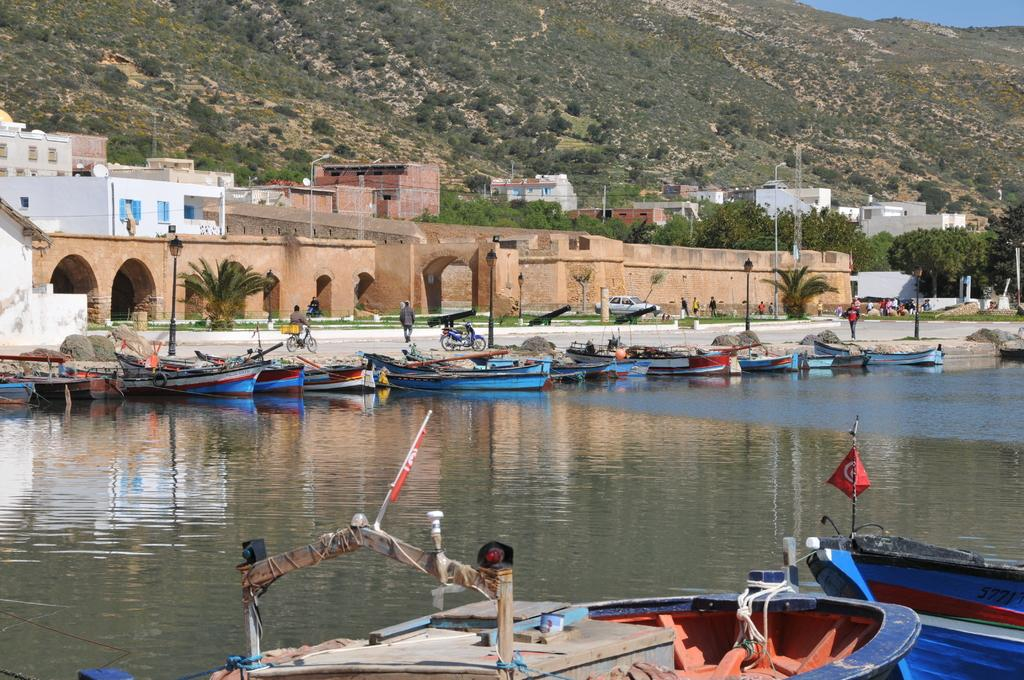What is located at the bottom of the image? There is a boat at the bottom of the image. What is in the center of the image? There is water in the center of the image. How many boats can be seen in the image? There are multiple boats in the image. What can be seen in the background of the image? There are buildings and mountains in the background of the image. What type of soda is being poured from a bottle in the image? There is no soda or bottle present in the image. What shape is the boat in the image? The shape of the boat cannot be determined from the image alone, as it is a two-dimensional representation. 